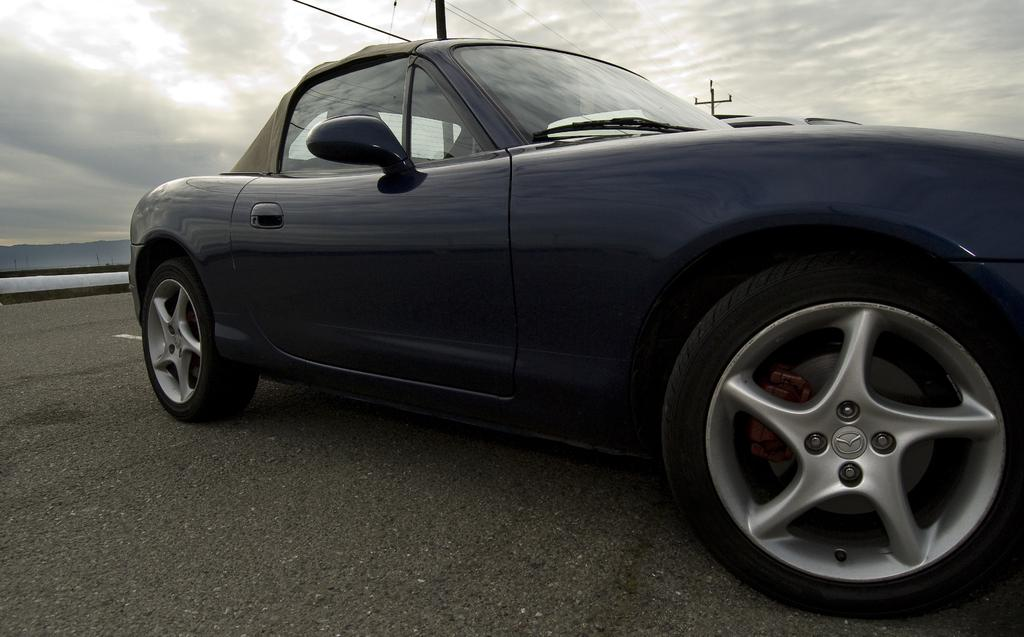What is the main subject of the image? The main subject of the image is a car. Can you describe the car in the image? The car is black in color. What can be seen in the background of the image? There is a road, a mountain, an electric pole, and electric wires in the image. How would you describe the weather in the image? The sky is cloudy in the image. What type of juice is being served at the car competition in the image? There is no juice or car competition present in the image. 